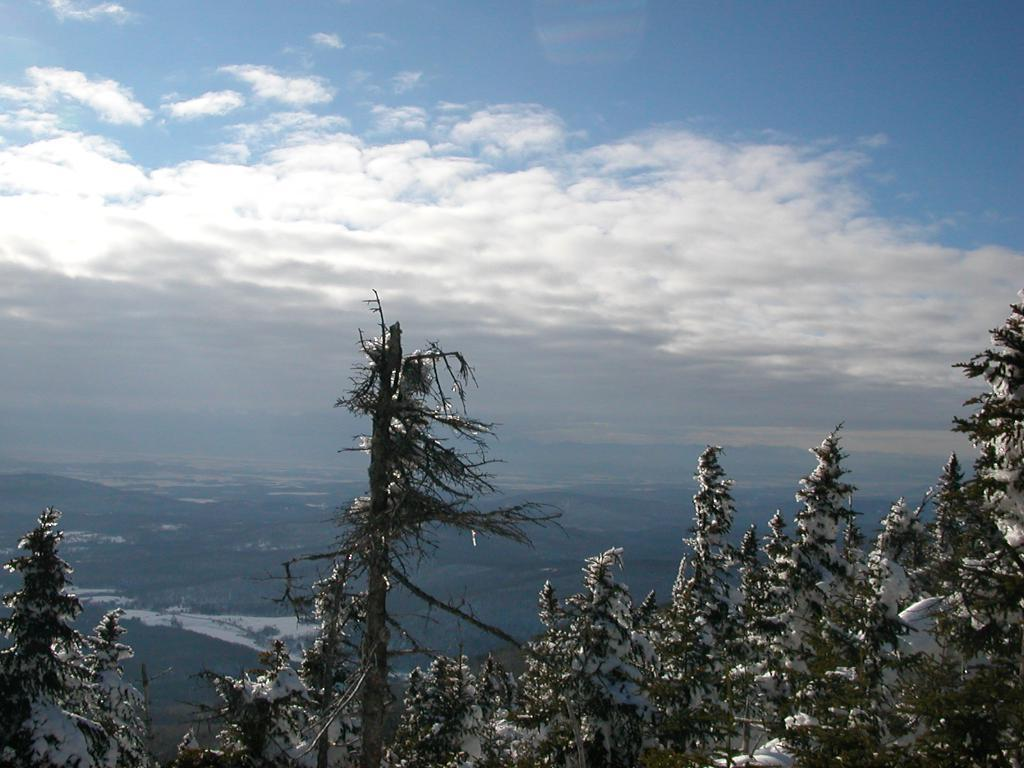What type of vegetation can be seen in the image? There are trees in the image. What is the weather like in the image? There is snow visible in the image, indicating a cold and snowy environment. What geographical features are present in the image? There are mountains in the image. What is the color of the sky in the image? The sky is blue and white in color. Can you see any quince trees in the image? There is no mention of quince trees in the image, so we cannot confirm their presence. How many stamps are visible on the mountains in the image? There are no stamps present in the image; it features trees, snow, mountains, and a blue and white sky. 